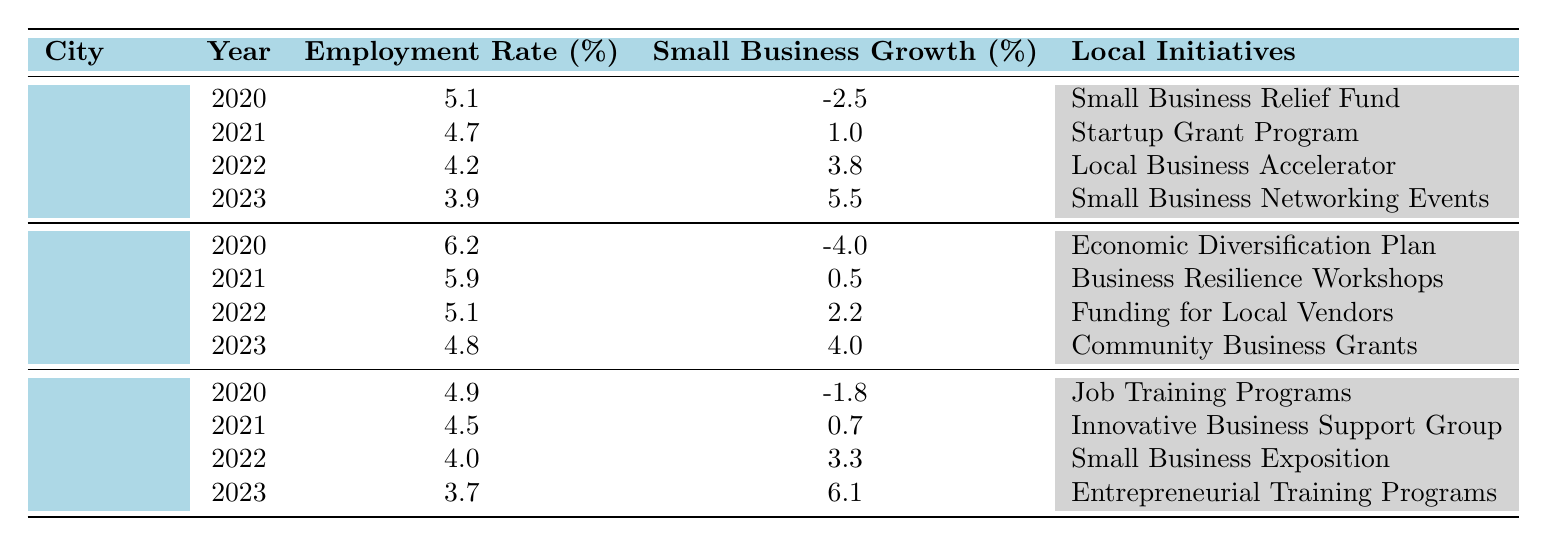What was the employment rate in Springfield in 2023? The table shows that in Springfield for the year 2023, the employment rate is listed as 3.9% in the relevant row.
Answer: 3.9% Which city's small business growth improved the most from 2020 to 2023? To determine this, we can look at the small business growth rates for each city in both years. Springfield's growth improved from -2.5% to 5.5%, a change of 8.0%. Riverdale's growth improved from -4.0% to 4.0, a change of 8.0%. Lakeside's growth improved from -1.8% to 6.1%, a change of 7.9%. Thus, both Springfield and Riverdale had the most significant improvement in small business growth.
Answer: Springfield and Riverdale In which year did Lakeside experience positive small business growth? We look through the rows for Lakeside and find positive growth figures in 2021 (0.7%), 2022 (3.3%), and 2023 (6.1%). The year Lakeside first experienced positive growth was 2021.
Answer: 2021 What was the average employment rate across all cities in 2021? To find the average, we first extract the employment rates for 2021: Springfield (4.7%), Riverdale (5.9%), and Lakeside (4.5%). We then sum these rates: 4.7 + 5.9 + 4.5 = 15.1%. Next, we divide this total by the number of cities (3), so 15.1/3 = 5.03%.
Answer: 5.03% Did any city have negative small business growth in 2022? We check the small business growth figures for 2022 for each city: Springfield (3.8%), Riverdale (2.2%), and Lakeside (3.3%). All values are positive, so no city had negative growth that year.
Answer: No What was the change in employment rate for Riverdale from 2020 to 2023? In 2020, Riverdale's employment rate was 6.2%, and in 2023 it was 4.8%. The change is calculated by subtracting the 2023 rate from the 2020 rate: 6.2% - 4.8% = 1.4%. This indicates a decrease in the employment rate.
Answer: 1.4% How much did small business growth increase in Springfield from 2021 to 2022? To find this, we compare the small business growth rates for Springfield in 2021 (1.0%) and 2022 (3.8%). The increase is calculated as 3.8% - 1.0% = 2.8%.
Answer: 2.8% 